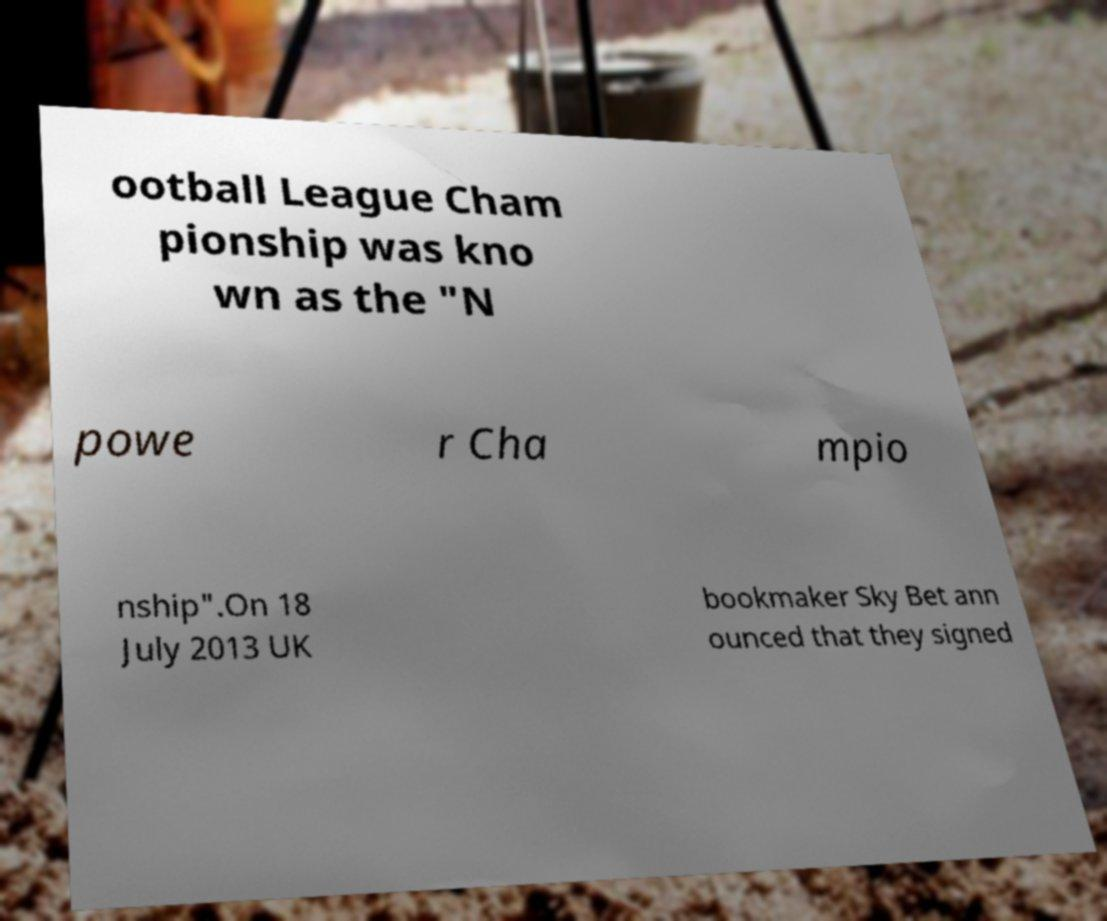Can you accurately transcribe the text from the provided image for me? ootball League Cham pionship was kno wn as the "N powe r Cha mpio nship".On 18 July 2013 UK bookmaker Sky Bet ann ounced that they signed 